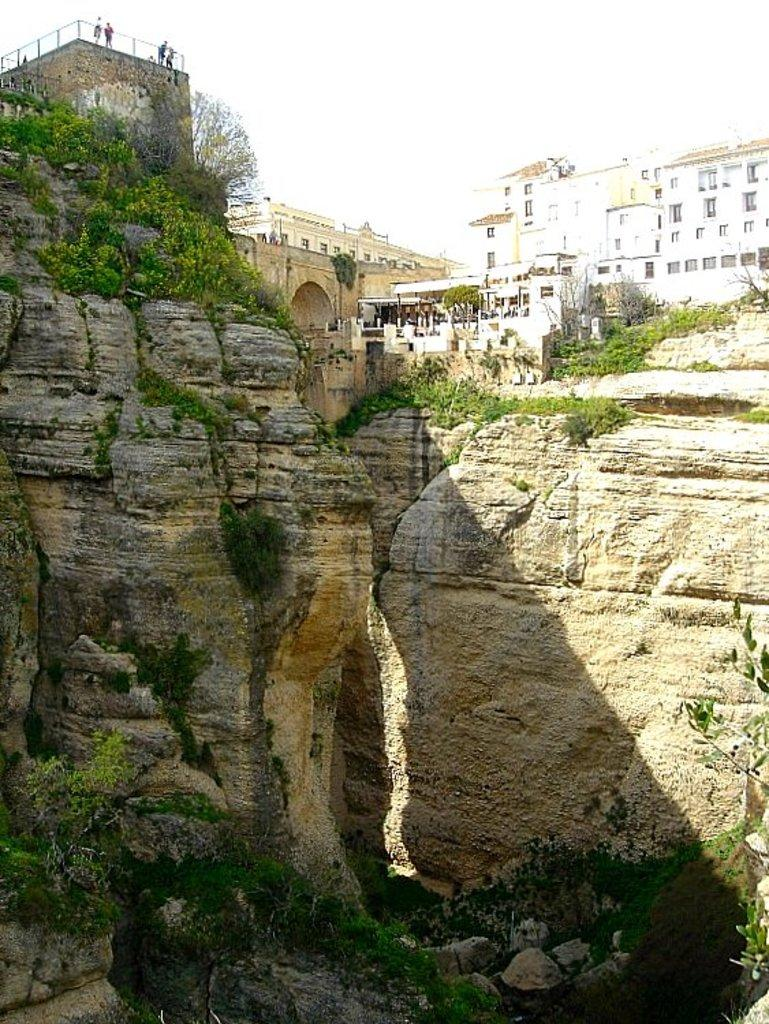What type of natural elements can be seen in the image? There are rocks and grass in the image. What type of structures are present in the image? There are buildings in the image. What type of vegetation is present in the image? There are trees in the image. Who or what else can be seen in the image? There are people in the image. What is visible at the top of the image? The sky is visible at the top of the image. How many lizards can be seen basking on the rocks in the image? There are no lizards present in the image; it features rocks, grass, buildings, trees, people, and a visible sky. What type of men are depicted in the image? There is no specific mention of men in the image; it simply shows people, which could include men, women, or children. 